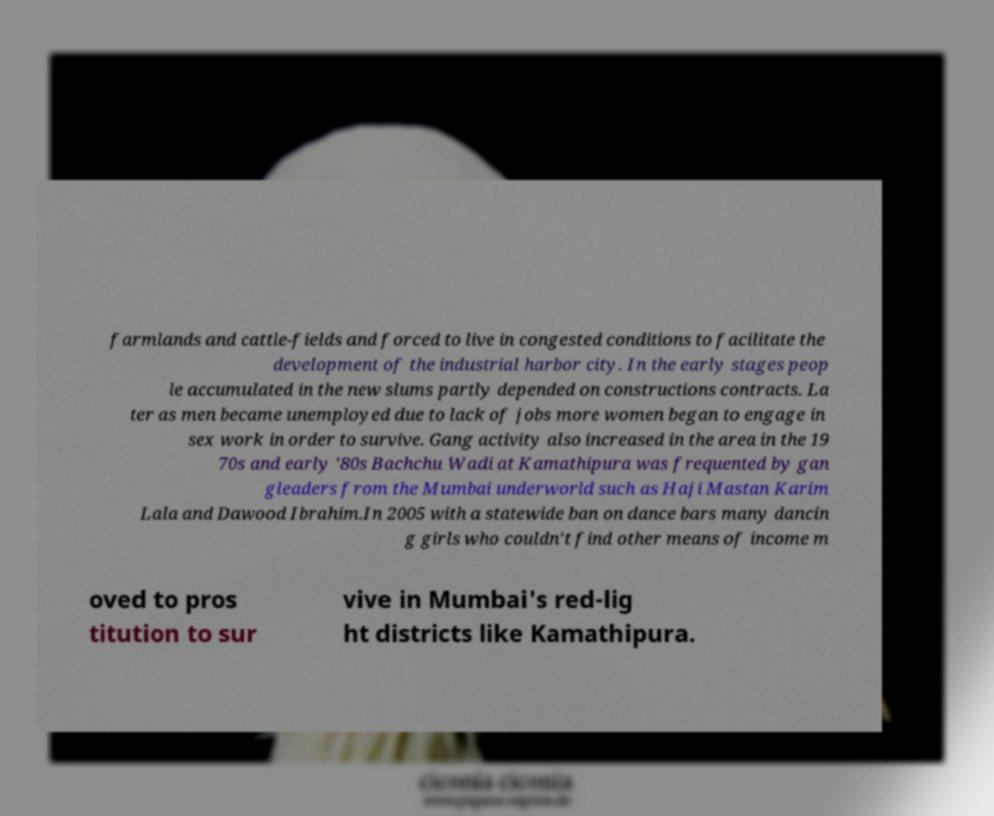For documentation purposes, I need the text within this image transcribed. Could you provide that? farmlands and cattle-fields and forced to live in congested conditions to facilitate the development of the industrial harbor city. In the early stages peop le accumulated in the new slums partly depended on constructions contracts. La ter as men became unemployed due to lack of jobs more women began to engage in sex work in order to survive. Gang activity also increased in the area in the 19 70s and early '80s Bachchu Wadi at Kamathipura was frequented by gan gleaders from the Mumbai underworld such as Haji Mastan Karim Lala and Dawood Ibrahim.In 2005 with a statewide ban on dance bars many dancin g girls who couldn't find other means of income m oved to pros titution to sur vive in Mumbai's red-lig ht districts like Kamathipura. 